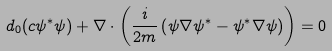Convert formula to latex. <formula><loc_0><loc_0><loc_500><loc_500>d _ { 0 } ( c \psi ^ { * } \psi ) + \nabla \cdot \left ( \frac { i } { 2 m } \left ( \psi \nabla \psi ^ { * } - \psi ^ { * } \nabla \psi \right ) \right ) = 0</formula> 